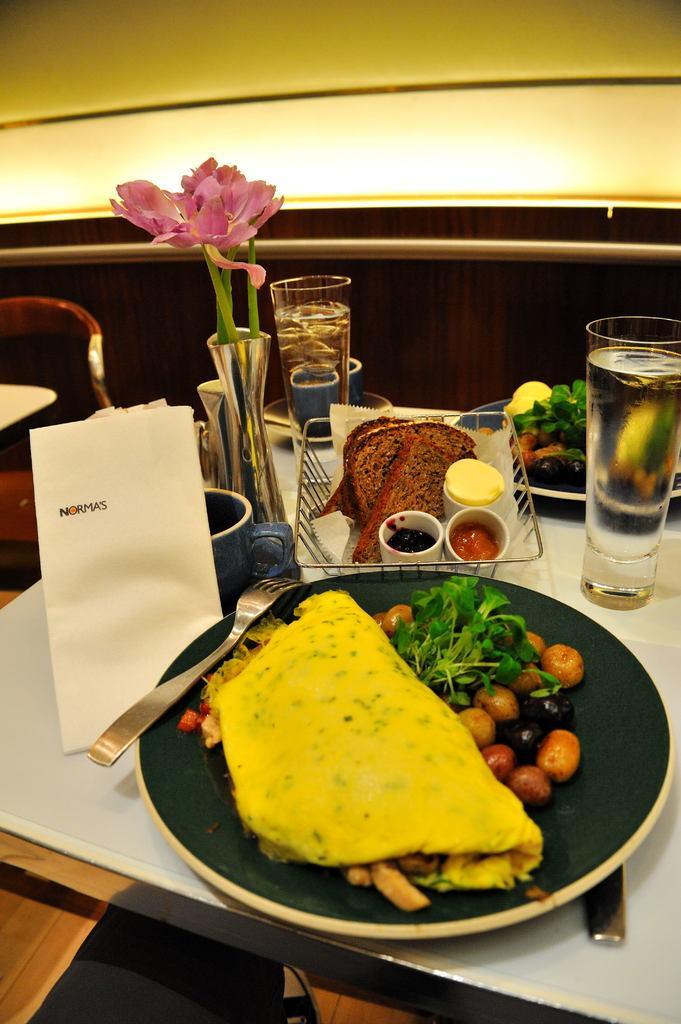Please provide a concise description of this image. On a dining table there is a food,fork,tissue,flower vase,glass with water. 